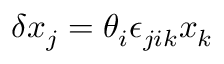Convert formula to latex. <formula><loc_0><loc_0><loc_500><loc_500>\delta x _ { j } = \theta _ { i } \epsilon _ { j i k } x _ { k }</formula> 